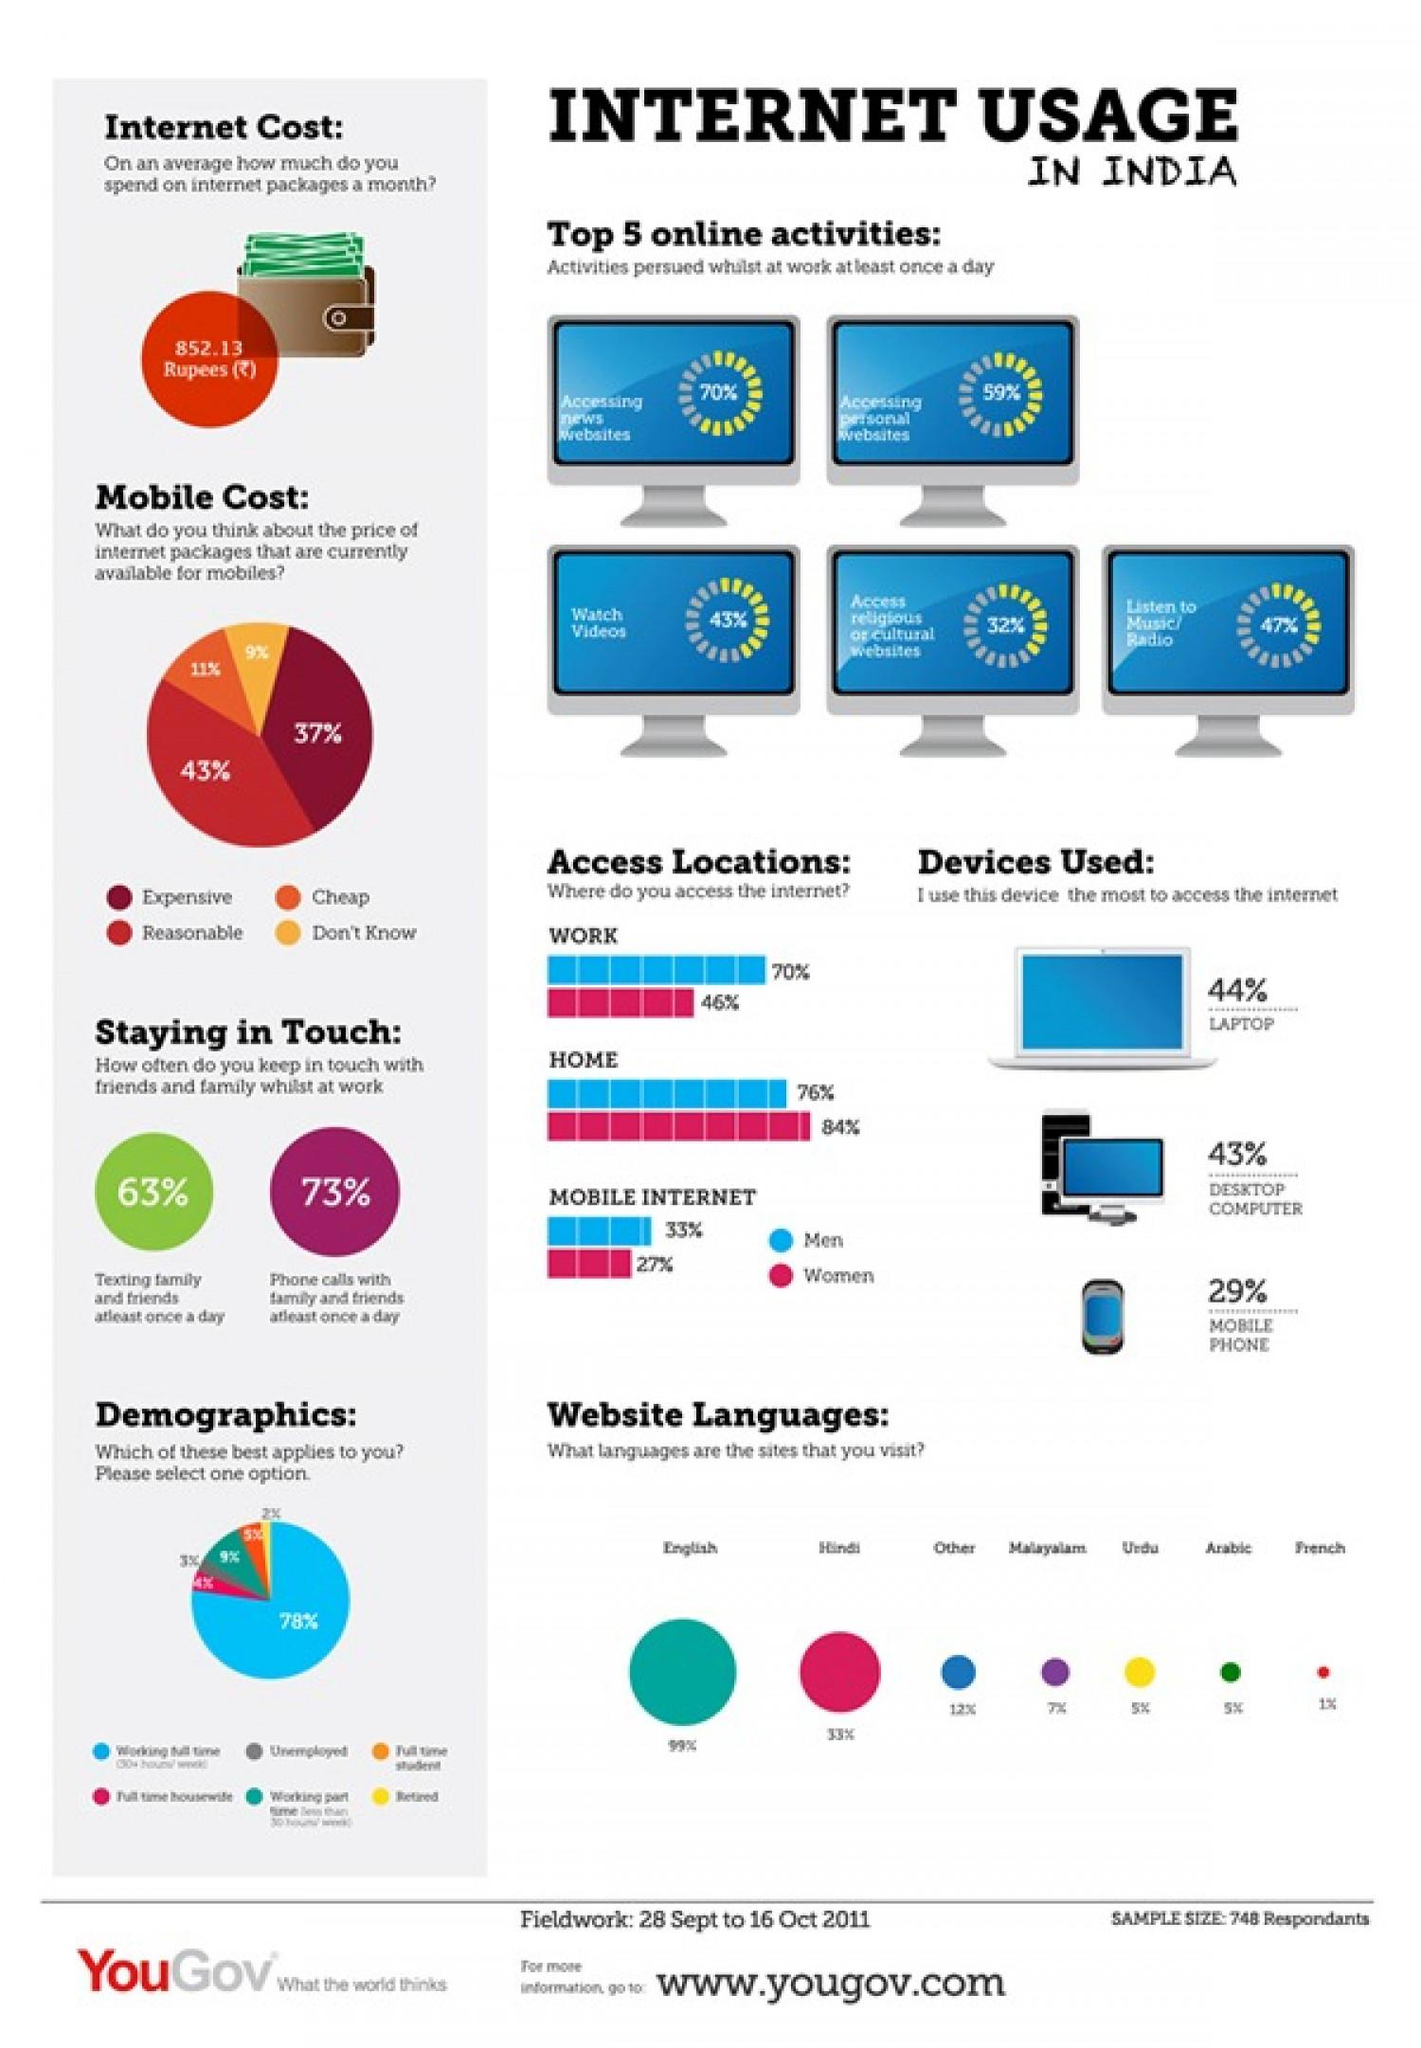Indicate a few pertinent items in this graphic. According to the survey, Hindi is the second most widely used website language among Indians. According to a survey, 37% of Indians believe that the current prices of mobile internet packages are too expensive. According to a survey, 47% of Indians report listening to music or the radio while at work at least once a day. According to the survey, English is the most widely used website language among Indians. According to a survey, 11% of Indians believe that the current prices of internet packages for mobile devices are reasonable. 